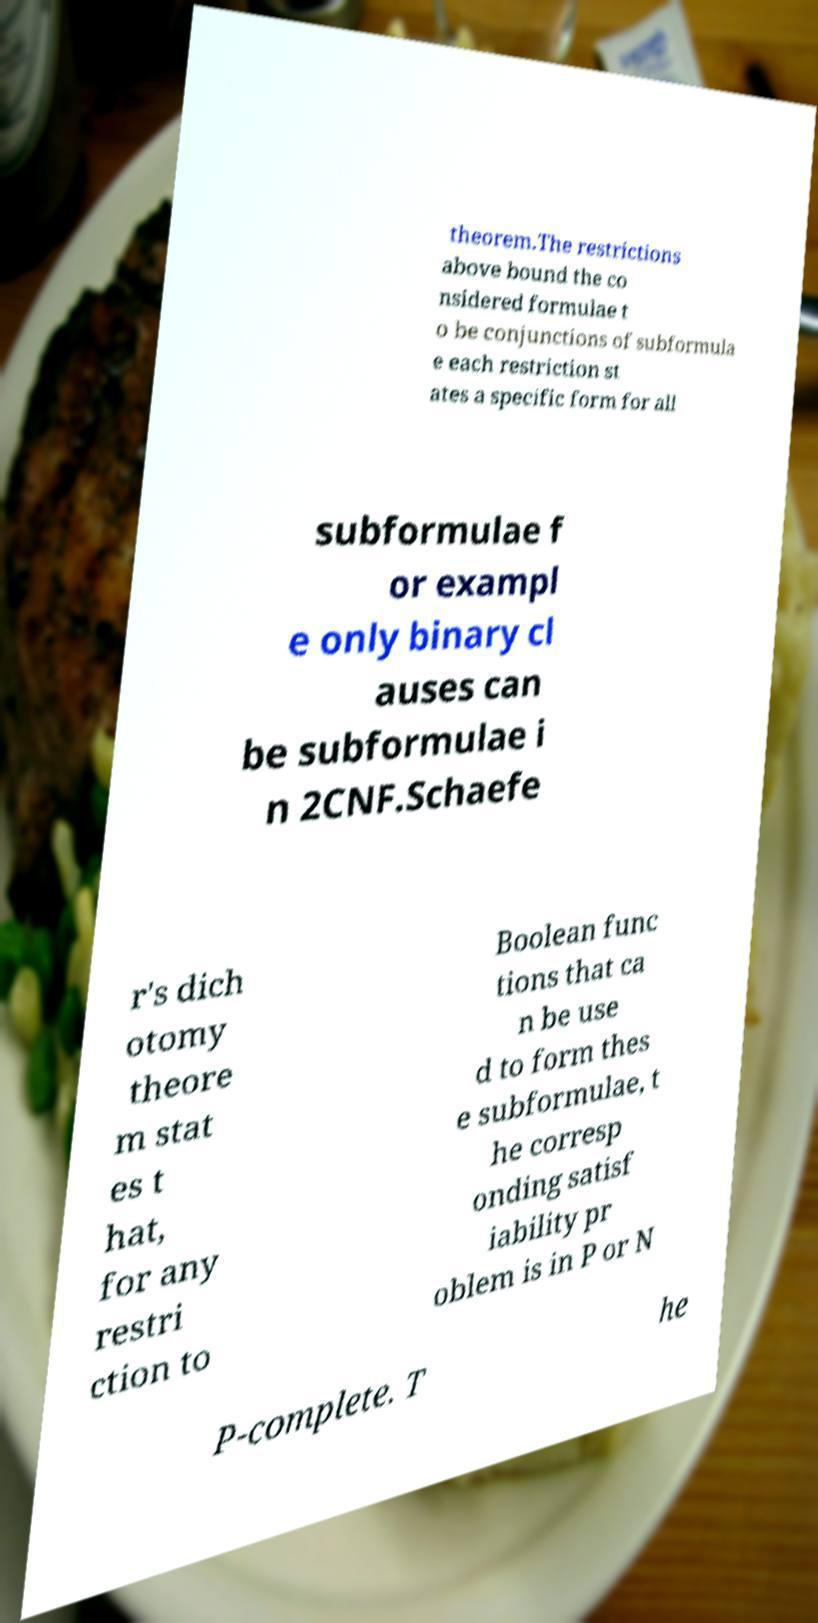I need the written content from this picture converted into text. Can you do that? theorem.The restrictions above bound the co nsidered formulae t o be conjunctions of subformula e each restriction st ates a specific form for all subformulae f or exampl e only binary cl auses can be subformulae i n 2CNF.Schaefe r's dich otomy theore m stat es t hat, for any restri ction to Boolean func tions that ca n be use d to form thes e subformulae, t he corresp onding satisf iability pr oblem is in P or N P-complete. T he 